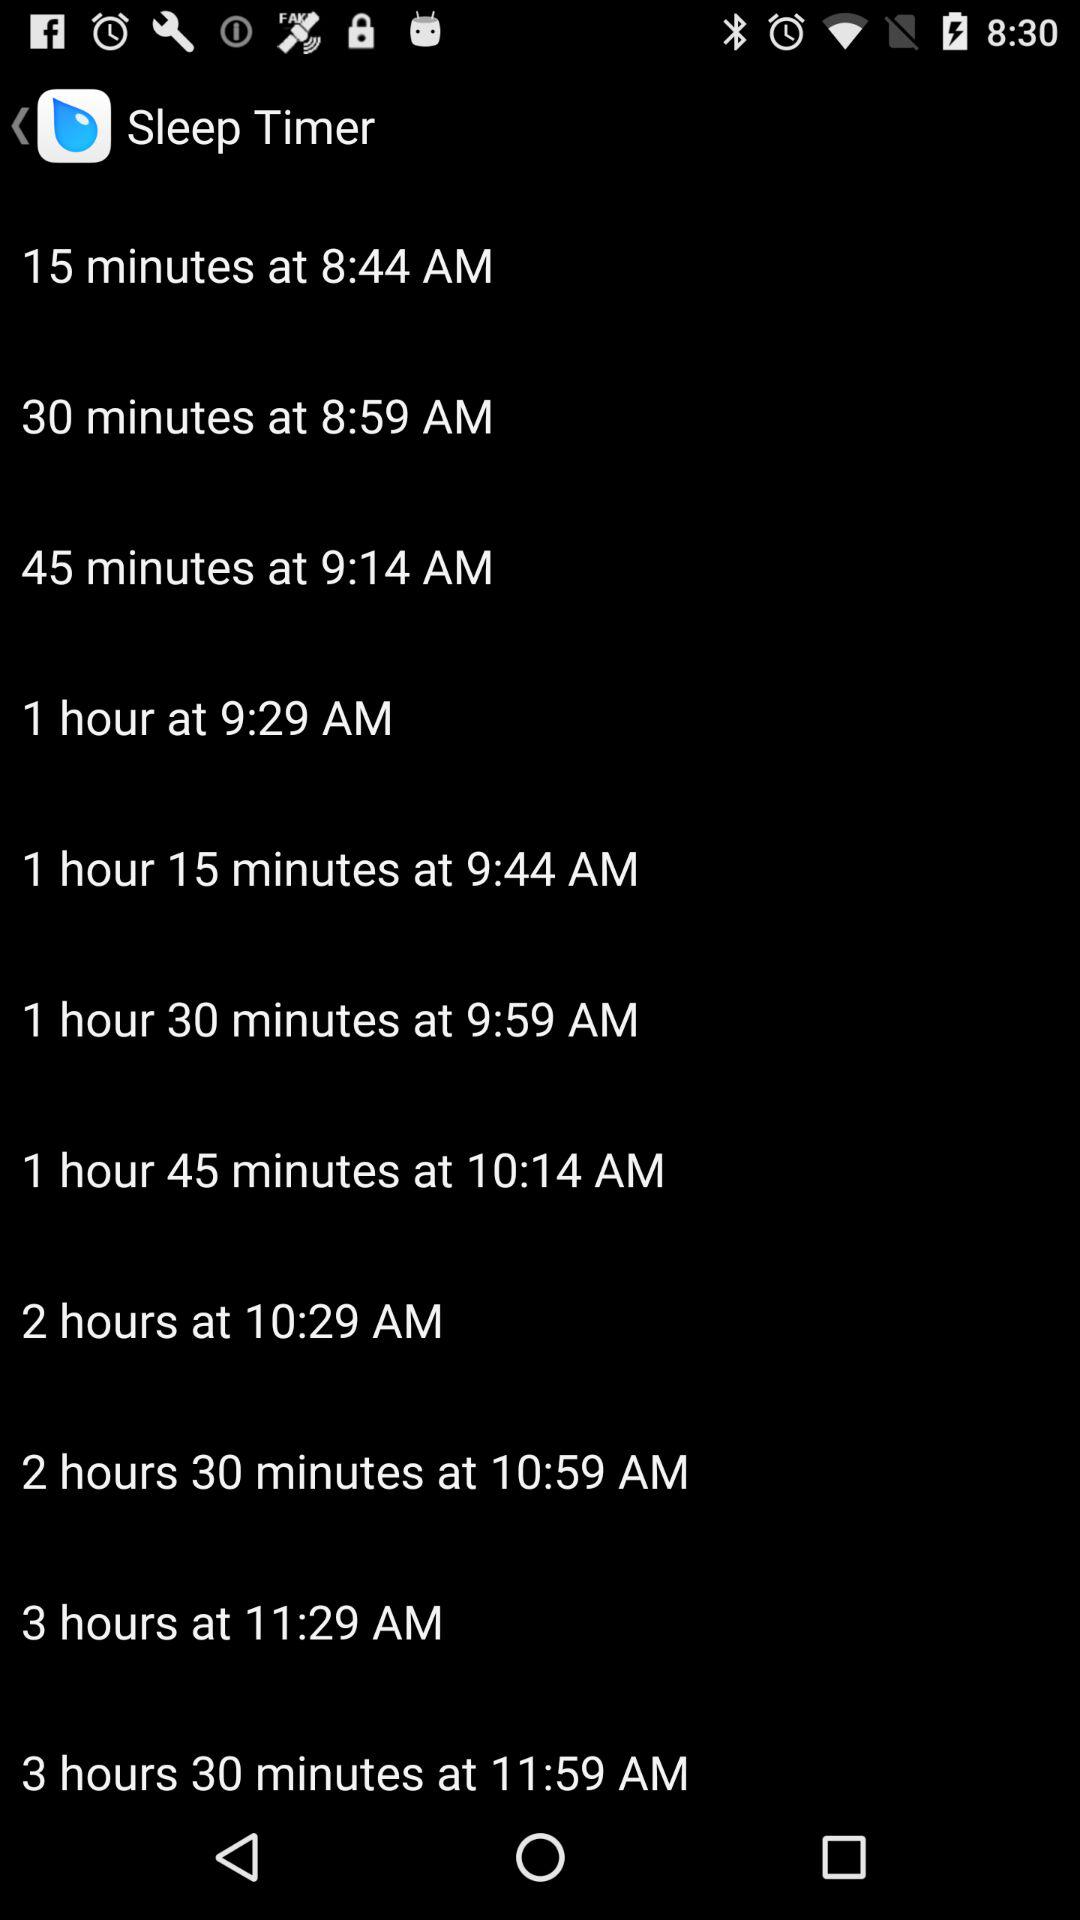How many minutes is the longest sleep timer option?
Answer the question using a single word or phrase. 3 hours 30 minutes 